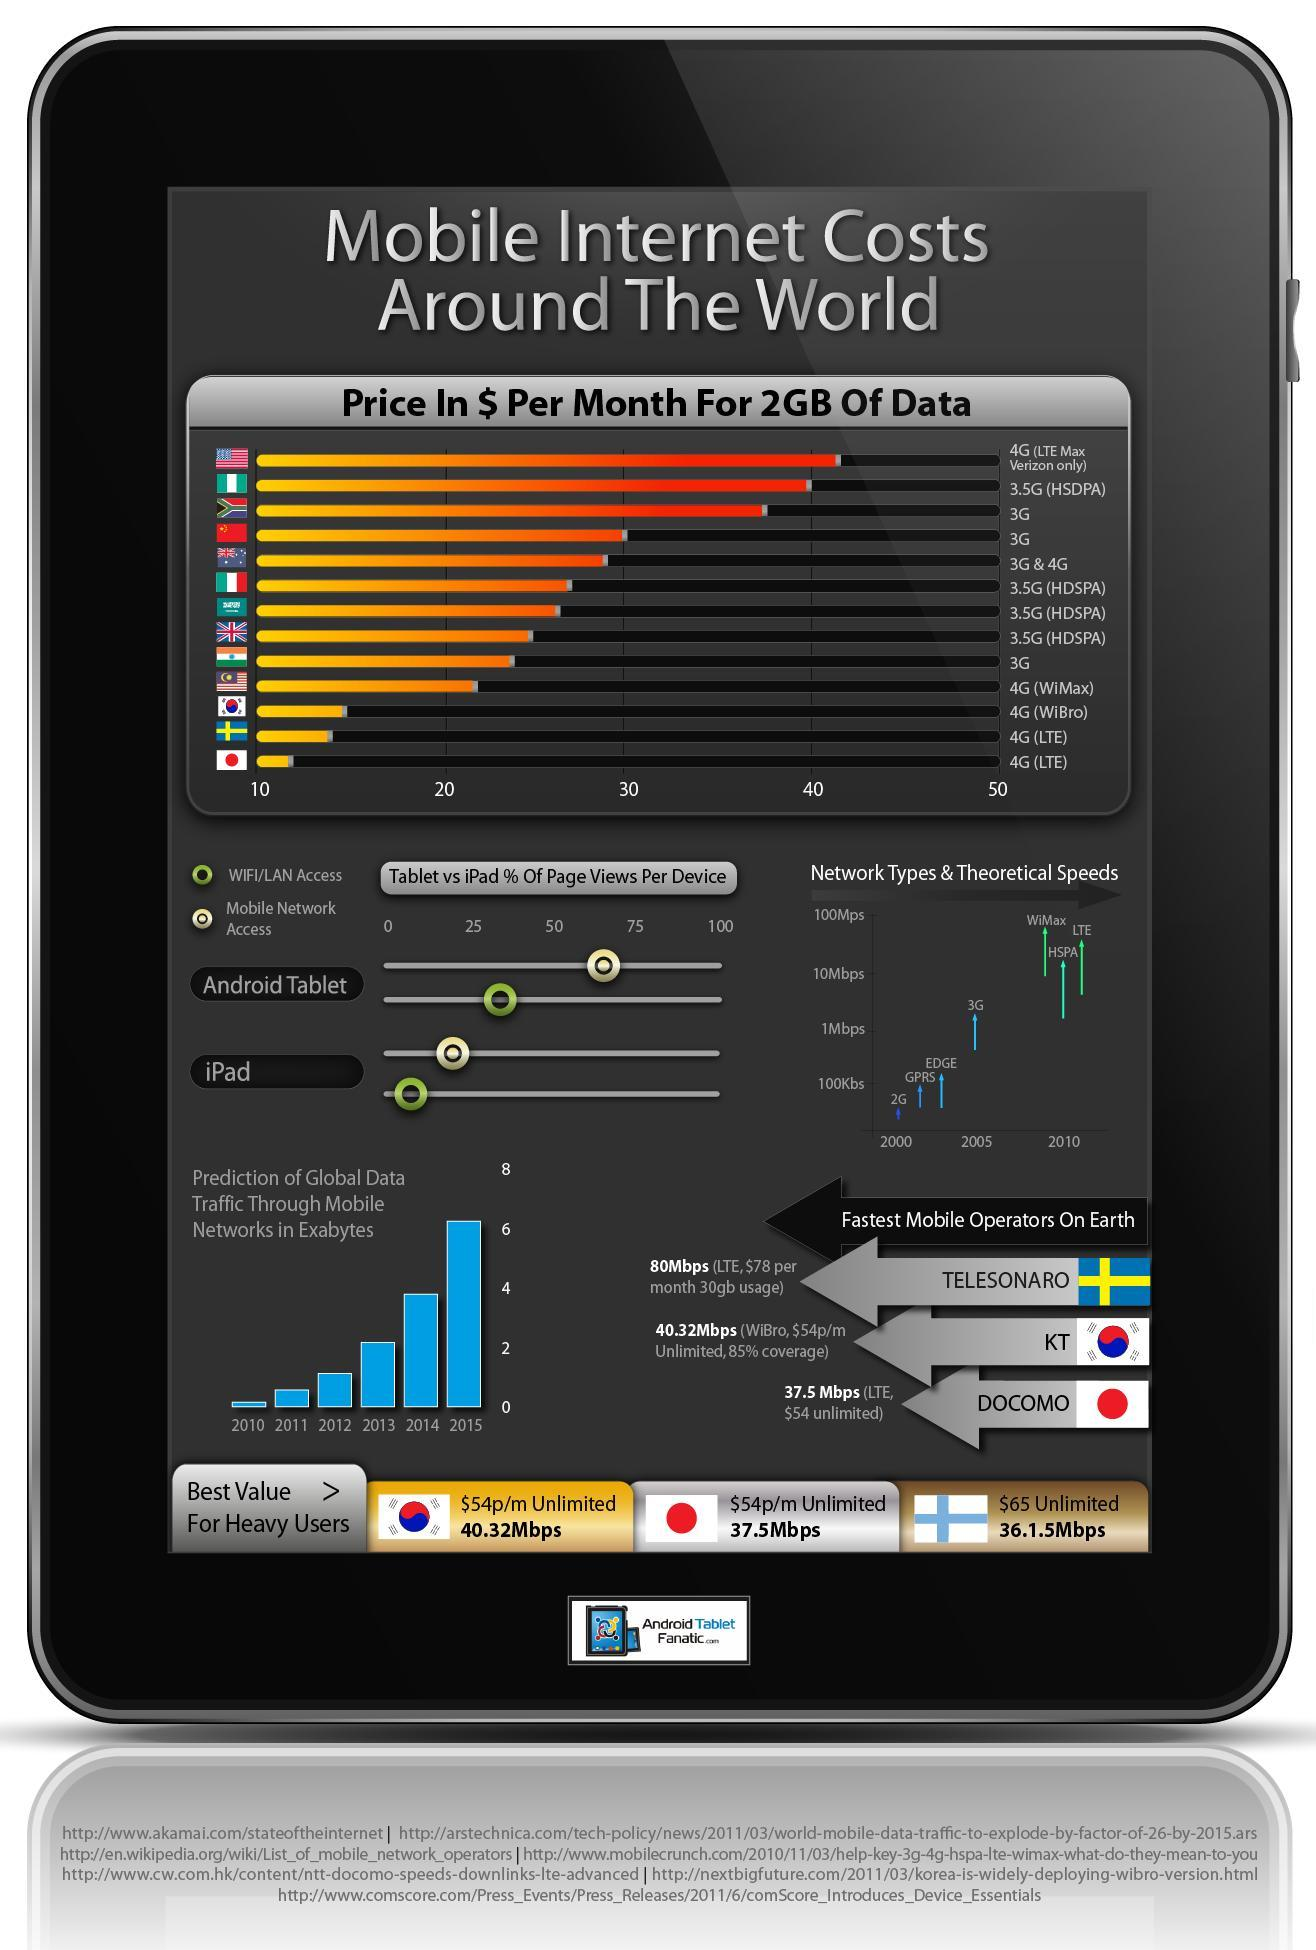How many connections has mobile internet costs more than 35 dollars?
Answer the question with a short phrase. 3 Which country is the best to get 4G LTE smart phone- India, America, Japan, Australia? Japan Which network type has third fastest speed in 2010? HSPA Which country has the third fastest mobile operators- China, Japan, India, America?? Japan Which country is the best to get 3G- Japan, India, Britain, America? India What is the global data traffic in exabytes in 2012? 1 How many connections has mobile internet costs more than 40 dollars? 1 Which is the mobile operator from Japan which ranks third among the fastest mobile operators on earth? DOCOMO Which country is the best to get 3.5G HDSPA- Japan, Australia, Britain, America? Britain Which network type had second fastest speed in 2010? LTE 